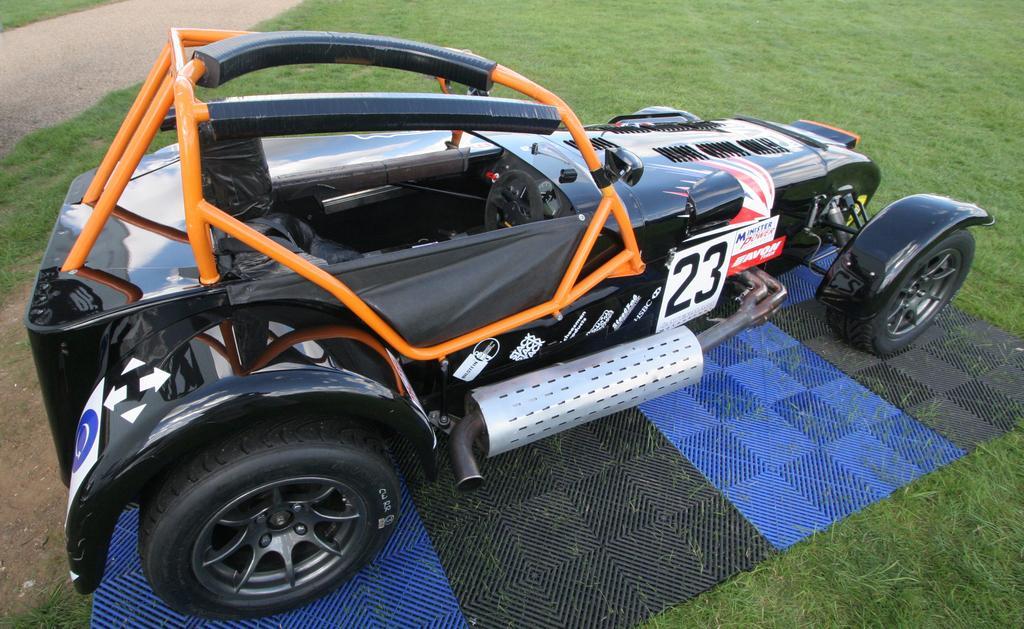Please provide a concise description of this image. In this image in front there is a car on the mat. At the bottom of the image there is grass on the surface. On the left side of the image there is a road. 